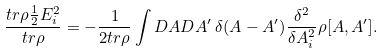<formula> <loc_0><loc_0><loc_500><loc_500>\frac { t r \rho \frac { 1 } { 2 } E _ { i } ^ { 2 } } { t r \rho } = - \frac { 1 } { 2 t r \rho } \int D A D A ^ { \prime } \, \delta ( A - A ^ { \prime } ) \frac { \delta ^ { 2 } } { \delta A _ { i } ^ { 2 } } \rho [ A , A ^ { \prime } ] .</formula> 